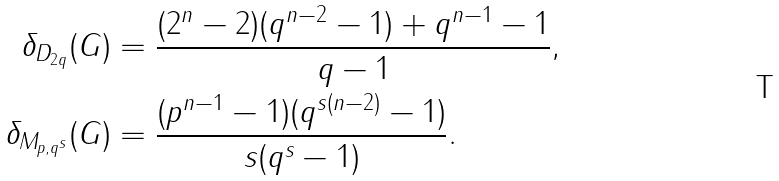<formula> <loc_0><loc_0><loc_500><loc_500>\delta _ { D _ { 2 q } } ( G ) & = \frac { ( 2 ^ { n } - 2 ) ( q ^ { n - 2 } - 1 ) + q ^ { n - 1 } - 1 } { q - 1 } , \\ \delta _ { M _ { p , q ^ { s } } } ( G ) & = \frac { ( p ^ { n - 1 } - 1 ) ( q ^ { s ( n - 2 ) } - 1 ) } { s ( q ^ { s } - 1 ) } .</formula> 